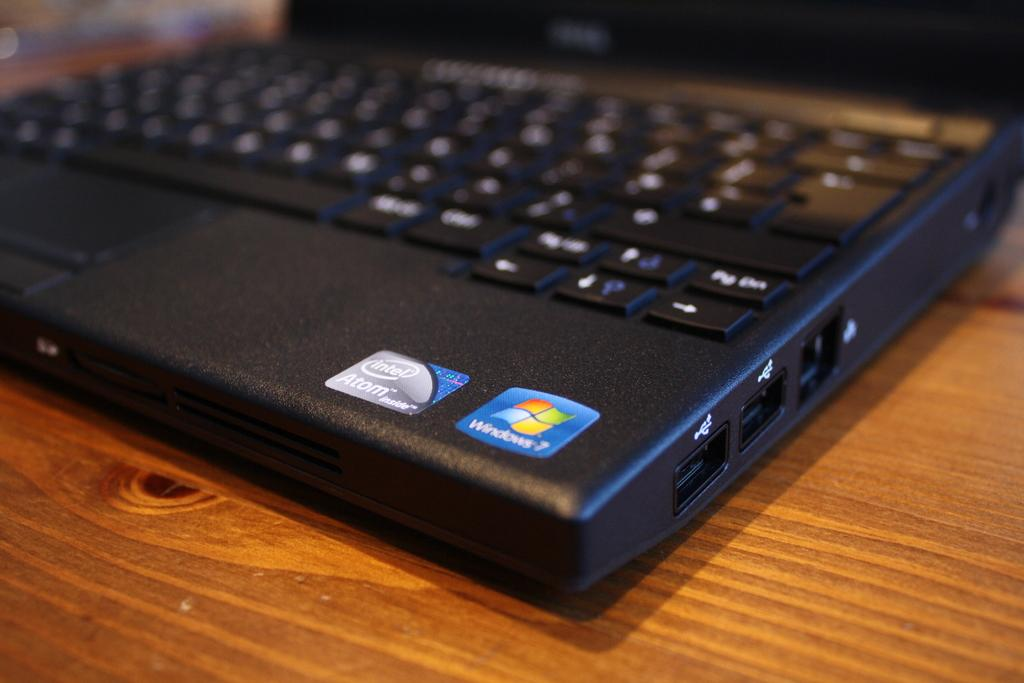<image>
Present a compact description of the photo's key features. A black laptop with a label of Windows 7 on it. 